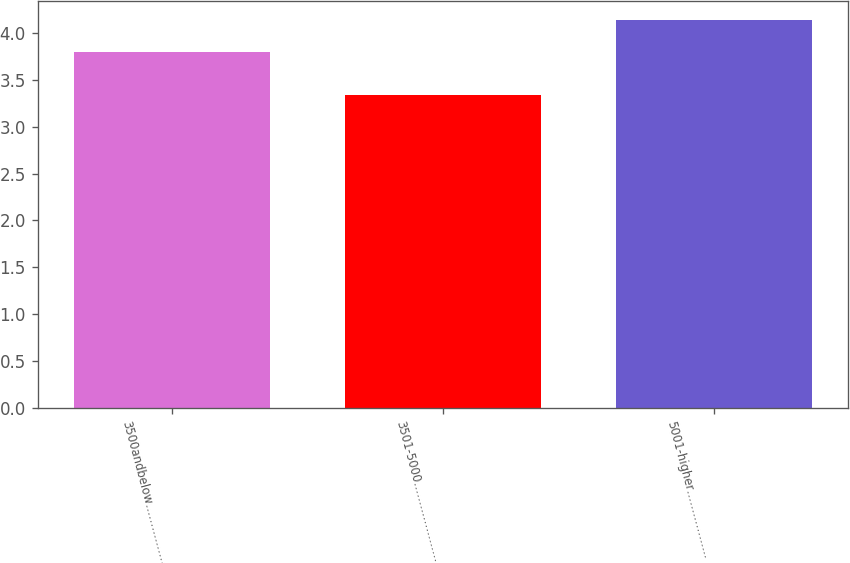Convert chart to OTSL. <chart><loc_0><loc_0><loc_500><loc_500><bar_chart><fcel>3500andbelow………………<fcel>3501-5000…………………<fcel>5001-higher………………<nl><fcel>3.8<fcel>3.34<fcel>4.14<nl></chart> 